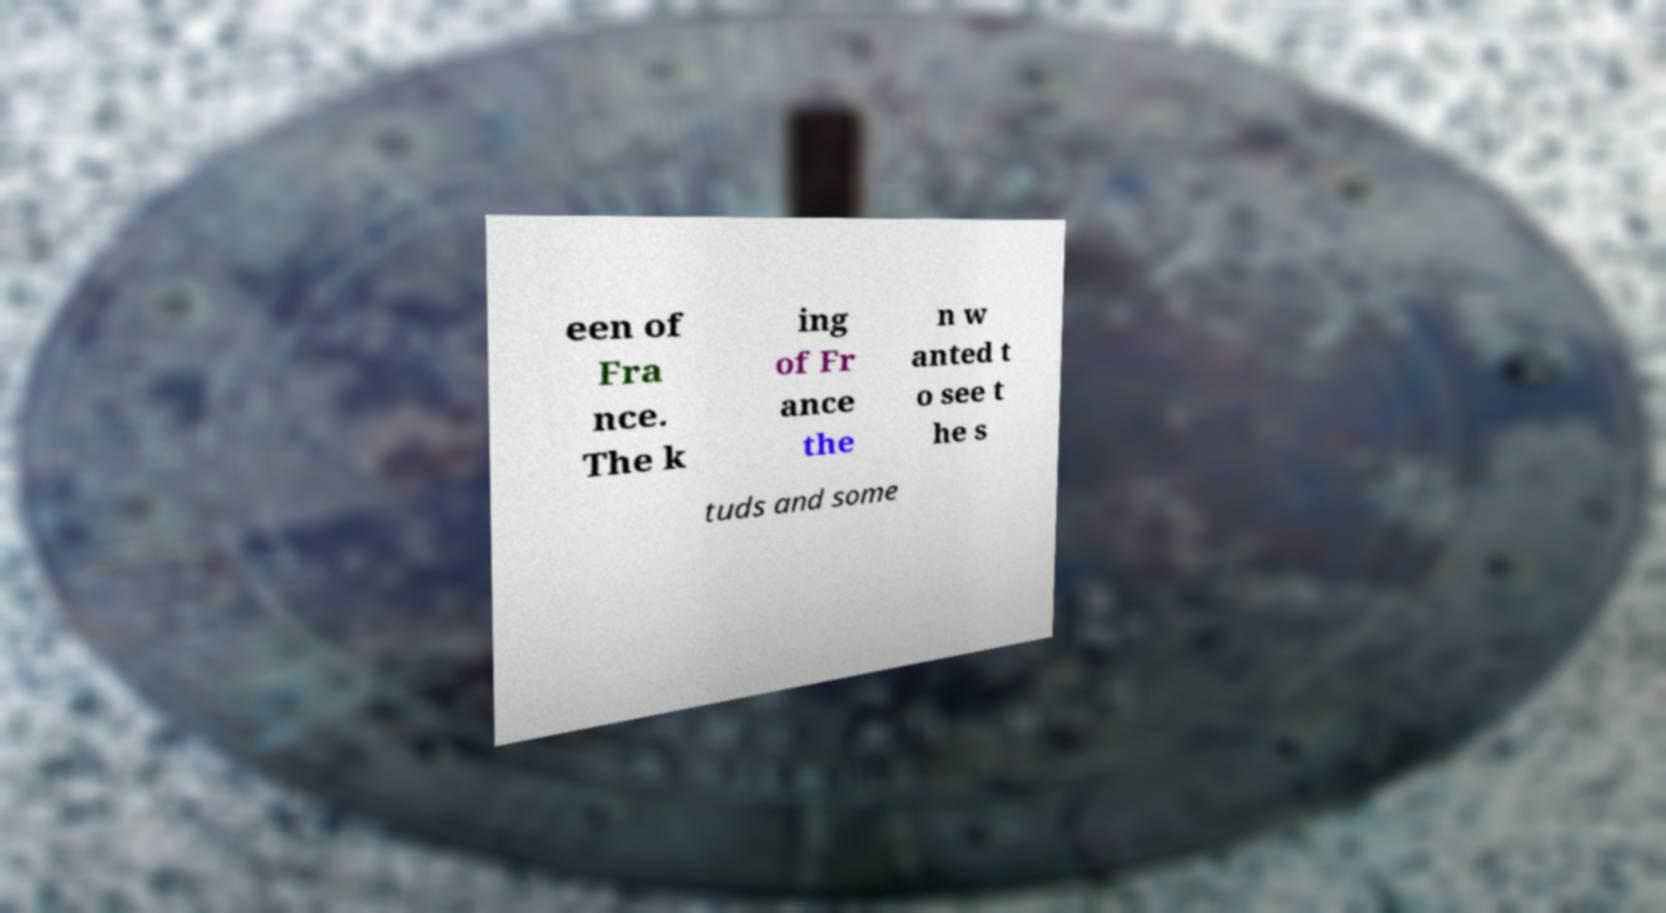Could you extract and type out the text from this image? een of Fra nce. The k ing of Fr ance the n w anted t o see t he s tuds and some 